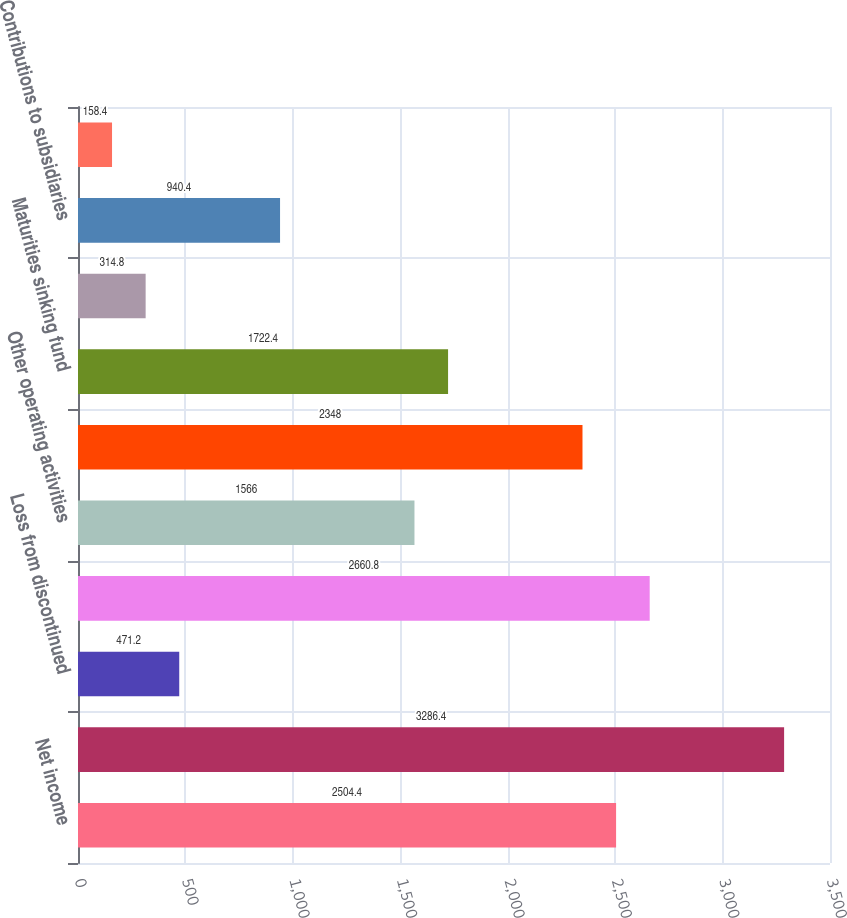Convert chart to OTSL. <chart><loc_0><loc_0><loc_500><loc_500><bar_chart><fcel>Net income<fcel>Equity in earnings of<fcel>Loss from discontinued<fcel>Dividends received from<fcel>Other operating activities<fcel>Net cash provided by operating<fcel>Maturities sinking fund<fcel>Purchase of land buildings<fcel>Contributions to subsidiaries<fcel>Return of capital from<nl><fcel>2504.4<fcel>3286.4<fcel>471.2<fcel>2660.8<fcel>1566<fcel>2348<fcel>1722.4<fcel>314.8<fcel>940.4<fcel>158.4<nl></chart> 